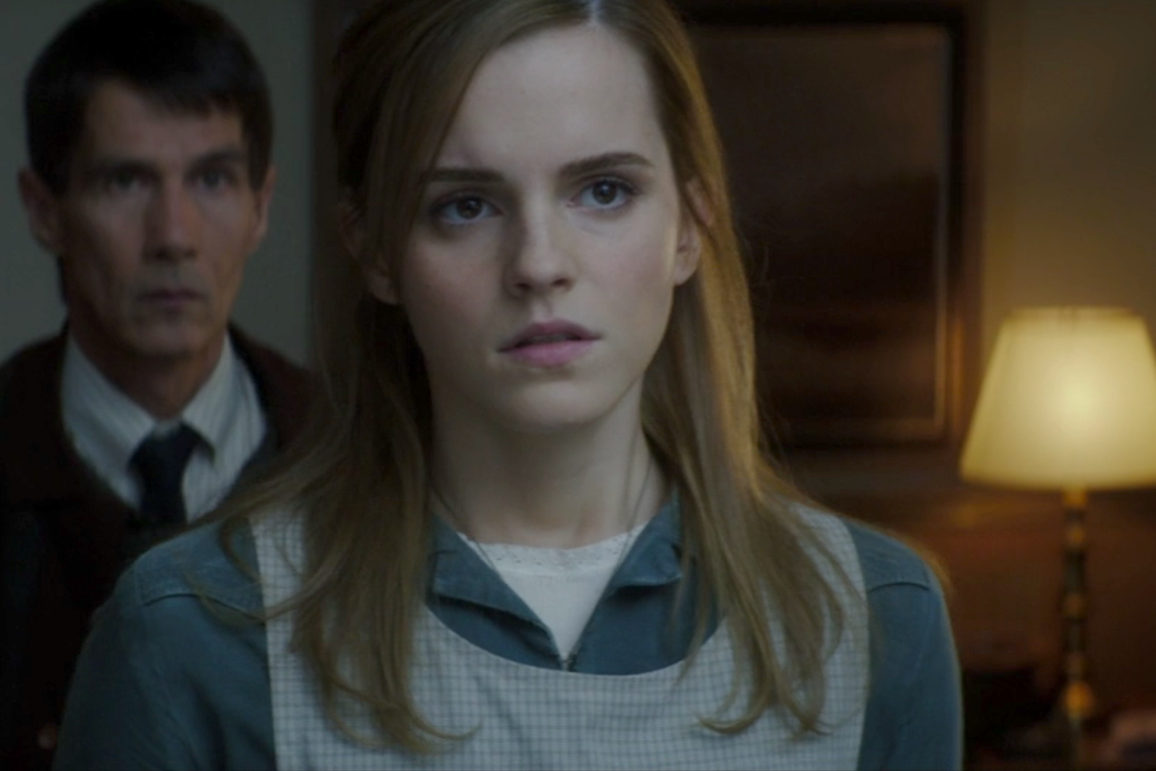What kind of story could be behind this image? This image might be from a dramatic scene in a film or TV show. The woman in the foreground, visibly distressed, seems to be at a pivotal moment. The man in the background, also appearing concerned, suggests they are both reacting to something significant happening off-screen. This could be a moment of realization or confrontation, where secrets are revealed or critical decisions are made. The dim lighting and shadows enhance the mood, adding a layer of suspense to the scene. 